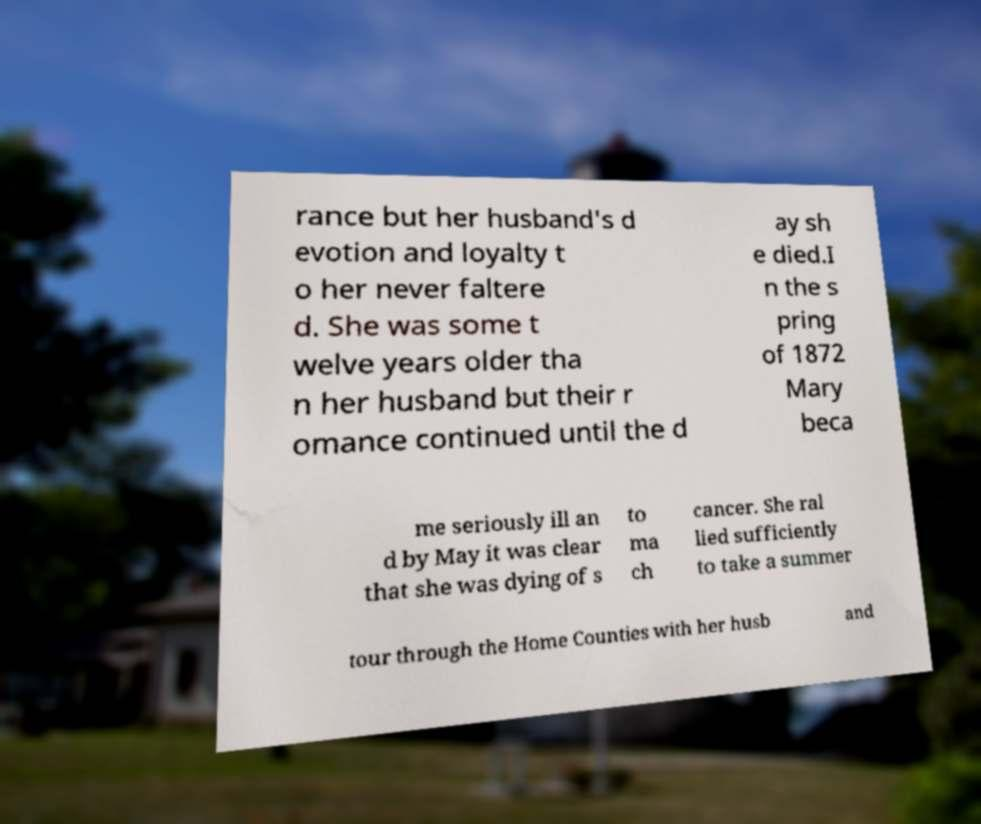Can you read and provide the text displayed in the image?This photo seems to have some interesting text. Can you extract and type it out for me? rance but her husband's d evotion and loyalty t o her never faltere d. She was some t welve years older tha n her husband but their r omance continued until the d ay sh e died.I n the s pring of 1872 Mary beca me seriously ill an d by May it was clear that she was dying of s to ma ch cancer. She ral lied sufficiently to take a summer tour through the Home Counties with her husb and 